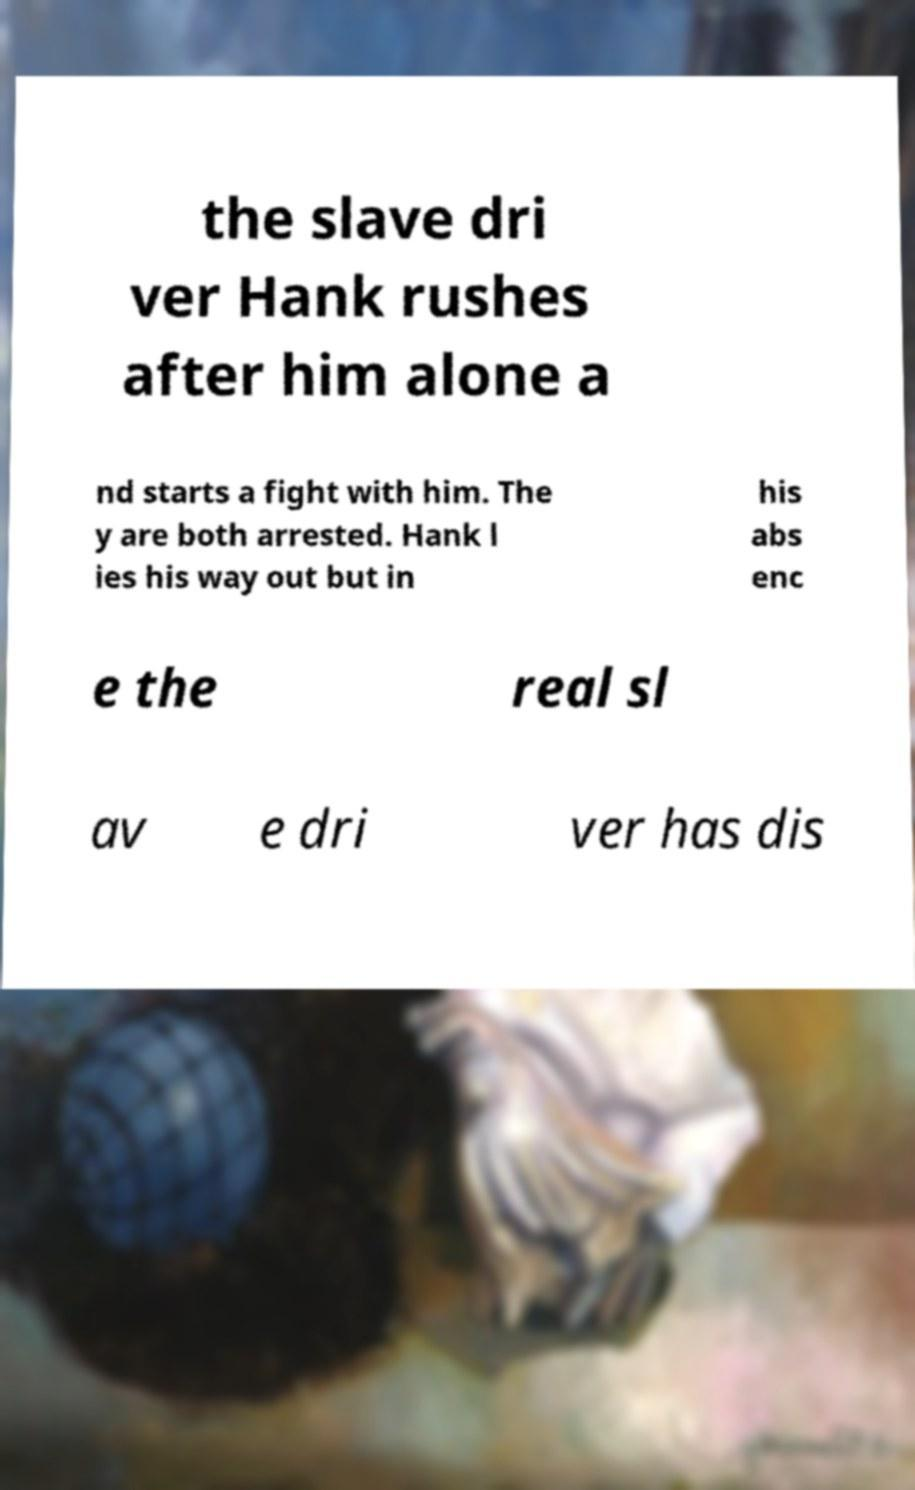I need the written content from this picture converted into text. Can you do that? the slave dri ver Hank rushes after him alone a nd starts a fight with him. The y are both arrested. Hank l ies his way out but in his abs enc e the real sl av e dri ver has dis 